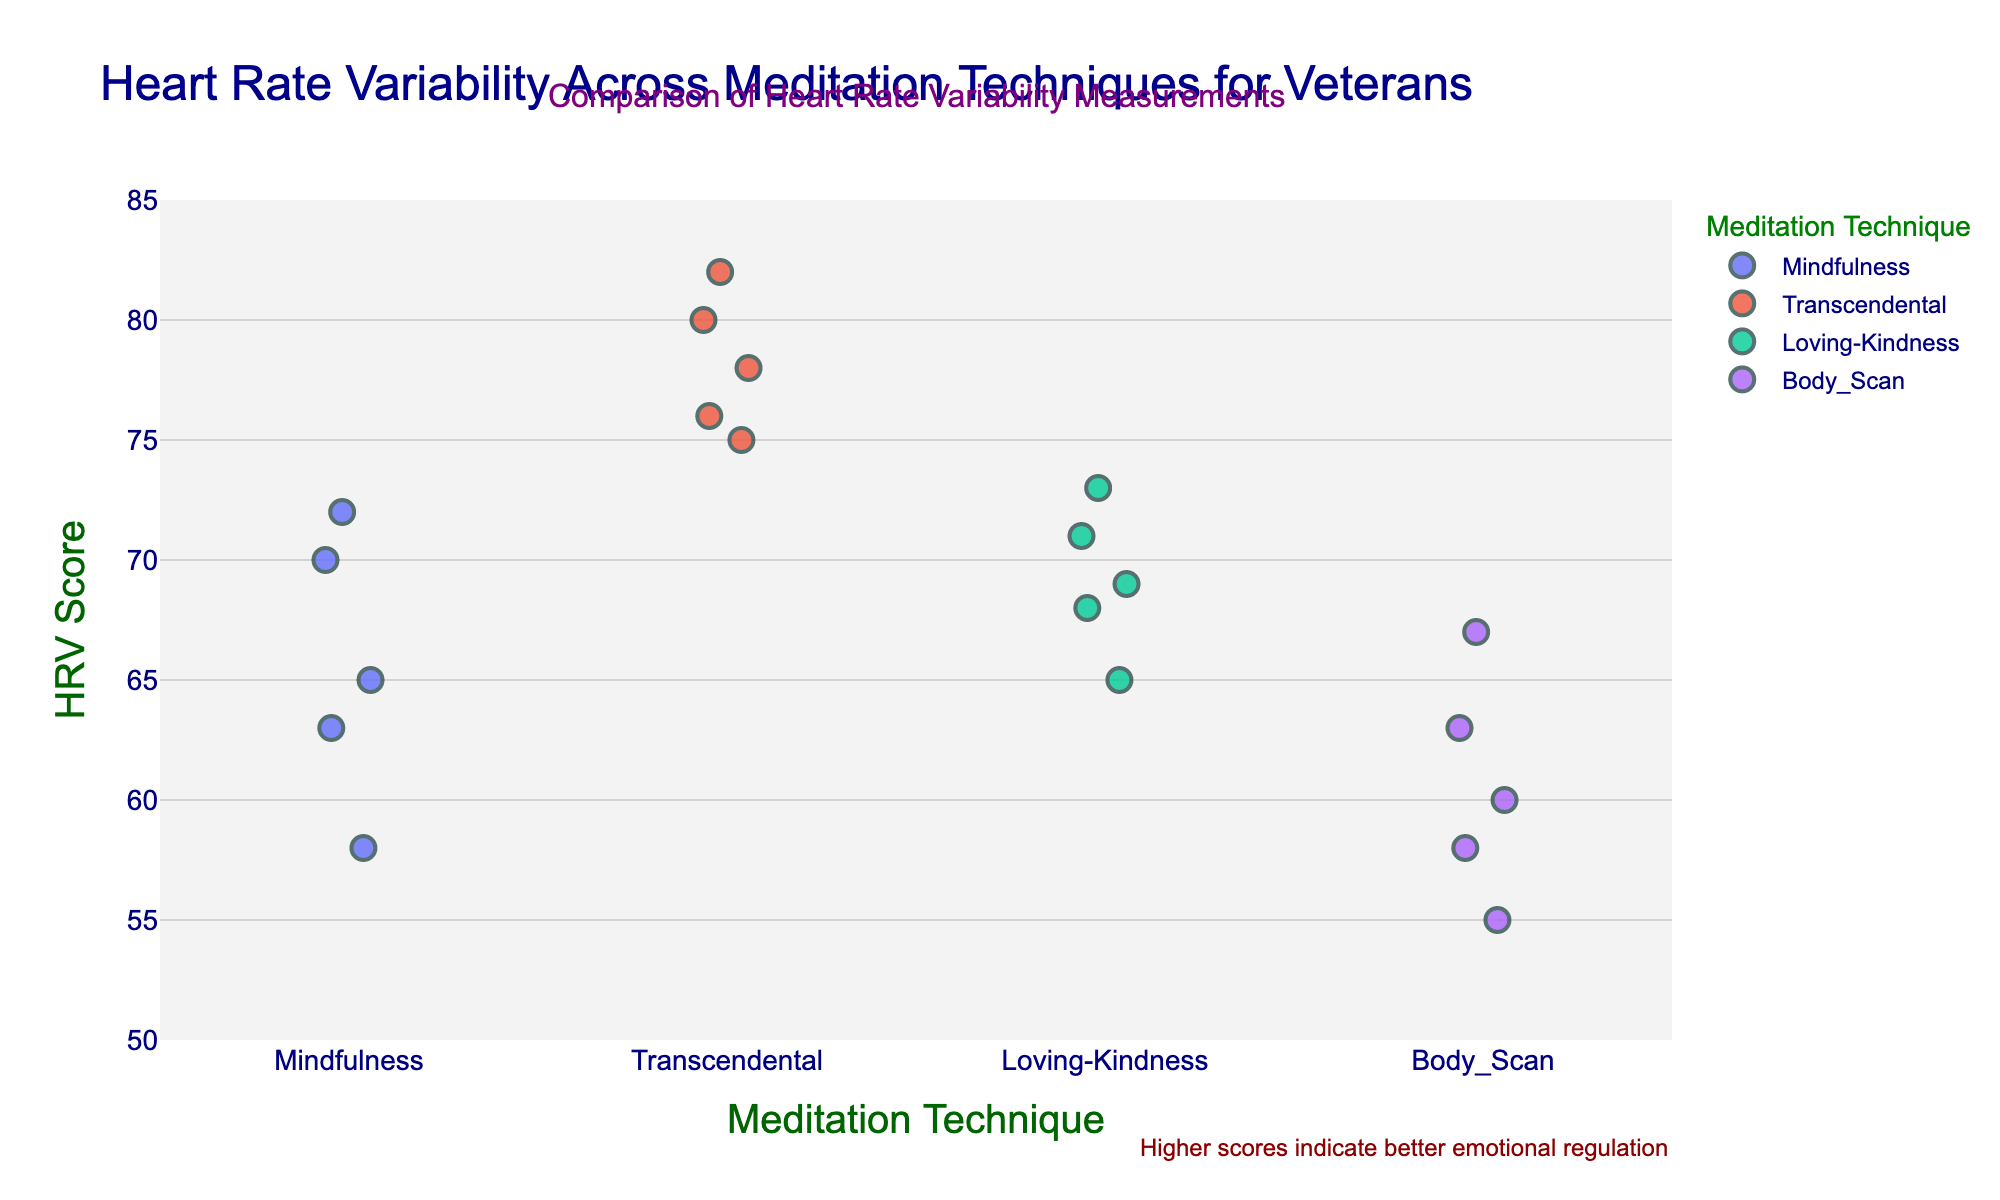What is the range of the Heart Rate Variability Scores on the y-axis? The y-axis in the plot ranges from 50 to 85, as indicated by the axis labels and tick marks.
Answer: 50 to 85 How many meditation techniques are compared in the plot? The x-axis shows four different meditation techniques: Mindfulness, Transcendental, Loving-Kindness, and Body Scan.
Answer: 4 Which meditation technique appears to have the highest Heart Rate Variability Scores? The Transcendental meditation technique has the highest scores ranging from 75 to 82, as shown by the data points concentrated towards the upper end of the range.
Answer: Transcendental What is the average Heart Rate Variability Score for the Mindfulness meditation technique? The HRV scores for Mindfulness are 65, 72, 58, 70, and 63. Summing these scores gives 328, and dividing by 5 yields an average of 65.6.
Answer: 65.6 How do the Heart Rate Variability Scores of Loving-Kindness compare to those of Body Scan? The Loving-Kindness scores range from 65 to 73, while the Body Scan scores range from 55 to 67. The Loving-Kindness range is higher overall compared to Body Scan.
Answer: Loving-Kindness scores are higher What is the Heart Rate Variability range for Transcendental meditation? The HRV scores for Transcendental meditation range from 75 to 82, as indicated by the data points on the y-axis.
Answer: 75 to 82 Which veteran shows the most improvement in Heart Rate Variability when comparing Mindfulness and Transcendental meditation? Veteran V002 shows a score of 72 for Mindfulness and 82 for Transcendental, an increase of 10 points.
Answer: V002 How many total data points are plotted? Each meditation technique has 5 data points, and there are 4 techniques, giving a total of 20 data points.
Answer: 20 What is the median Heart Rate Variability Score for the Body Scan technique? The scores for Body Scan are 55, 58, 60, 63, and 67. The median is the middle value, which is 60.
Answer: 60 